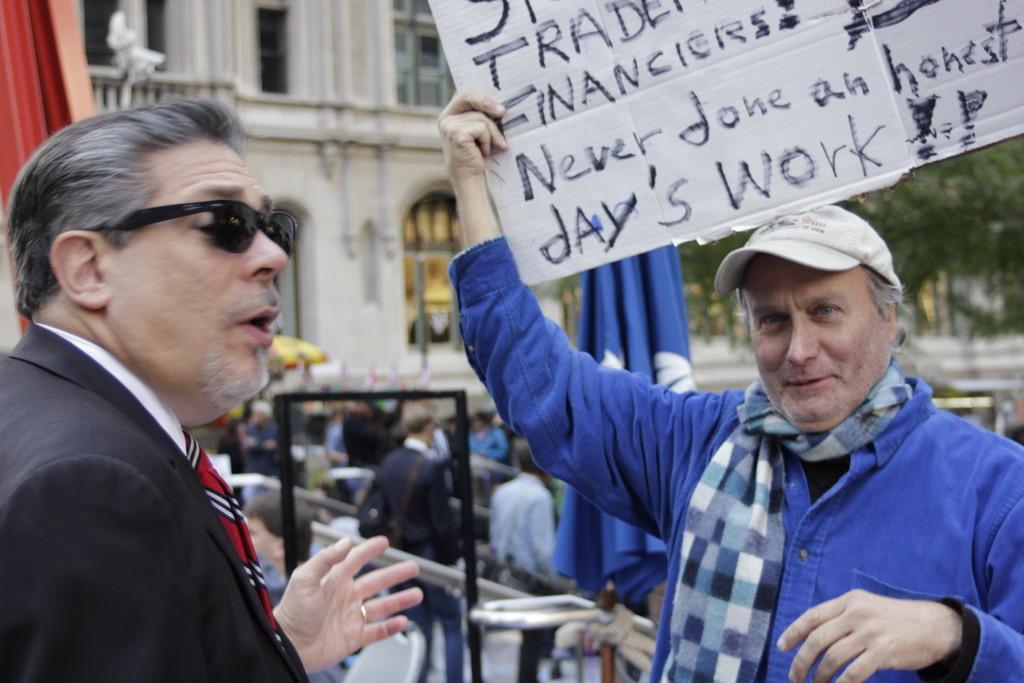In one or two sentences, can you explain what this image depicts? To the right side of the image there is a person wearing a blue color shirt holding a white color cardboard with some text on it. To the left side of the image there is a person wearing a suit. In the background of the image there is a building. There are people. To the right side of the image there are trees. 